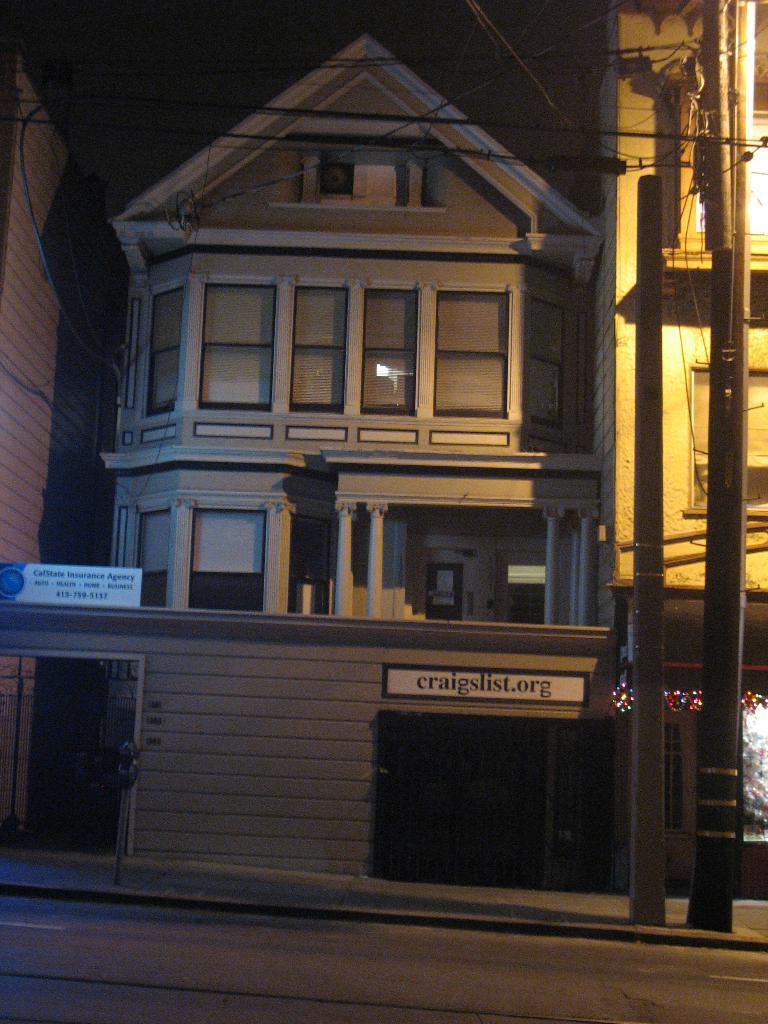Could you give a brief overview of what you see in this image? In this image we can see a few buildings, boards with some text written on, there are electric poles, wires, lights, also we can see some windows. 